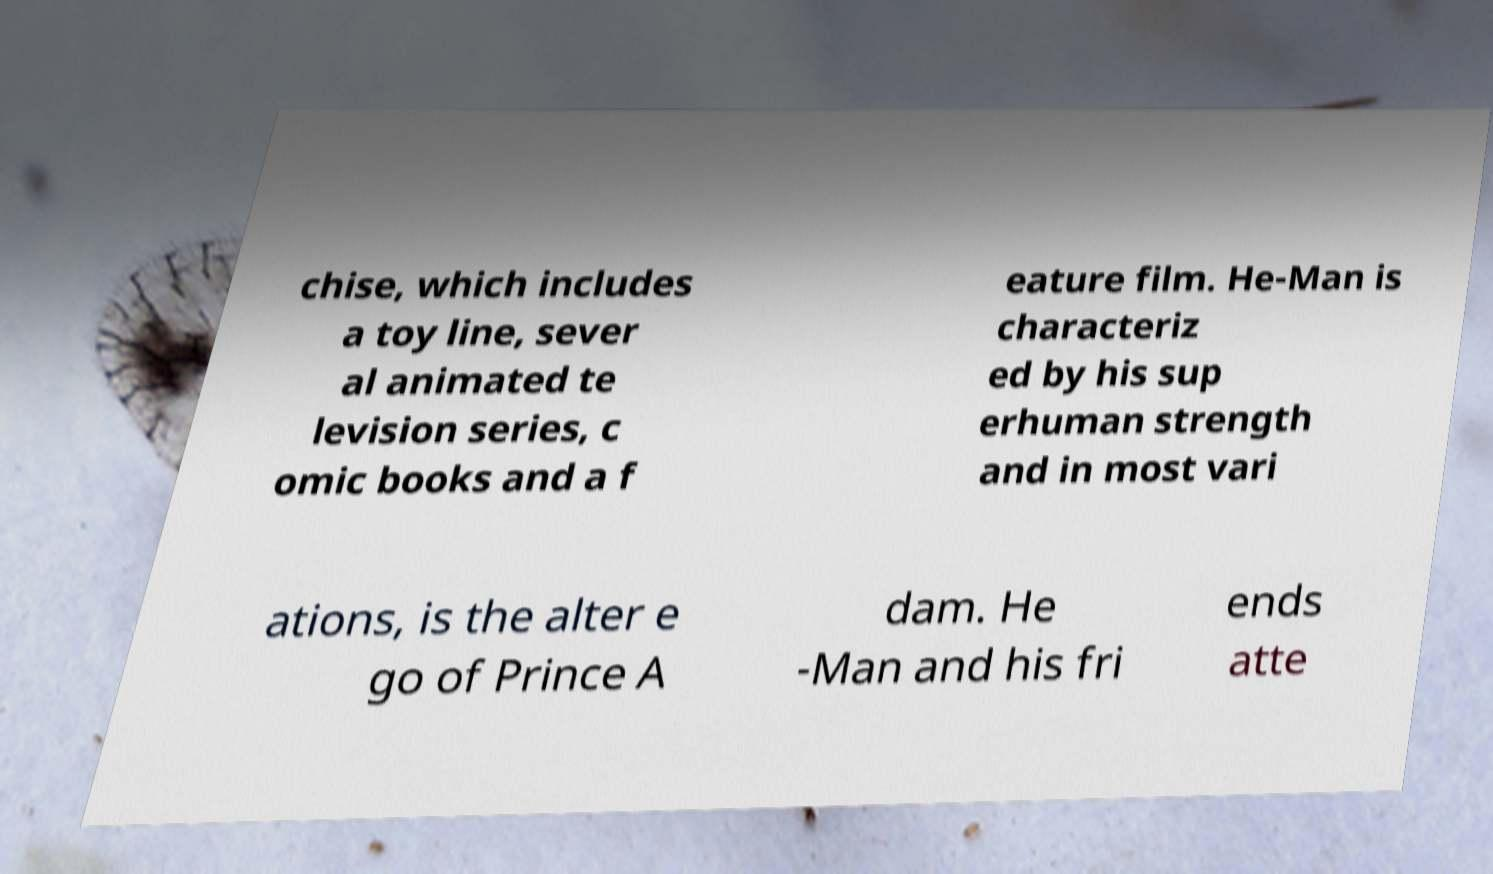There's text embedded in this image that I need extracted. Can you transcribe it verbatim? chise, which includes a toy line, sever al animated te levision series, c omic books and a f eature film. He-Man is characteriz ed by his sup erhuman strength and in most vari ations, is the alter e go of Prince A dam. He -Man and his fri ends atte 